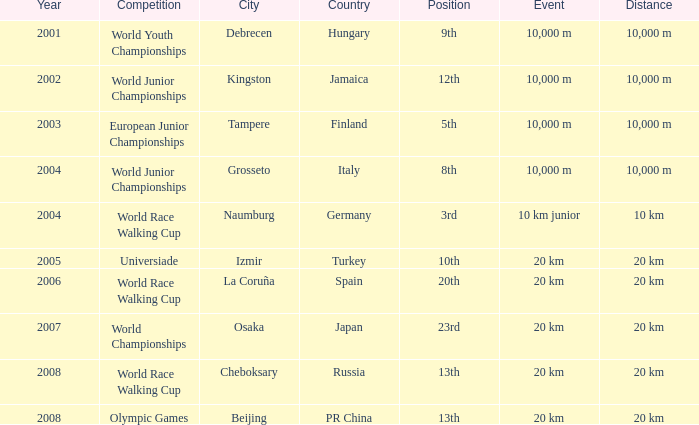Where did he manage to rank 3rd in the world race walking cup competition? Naumburg , Germany. 